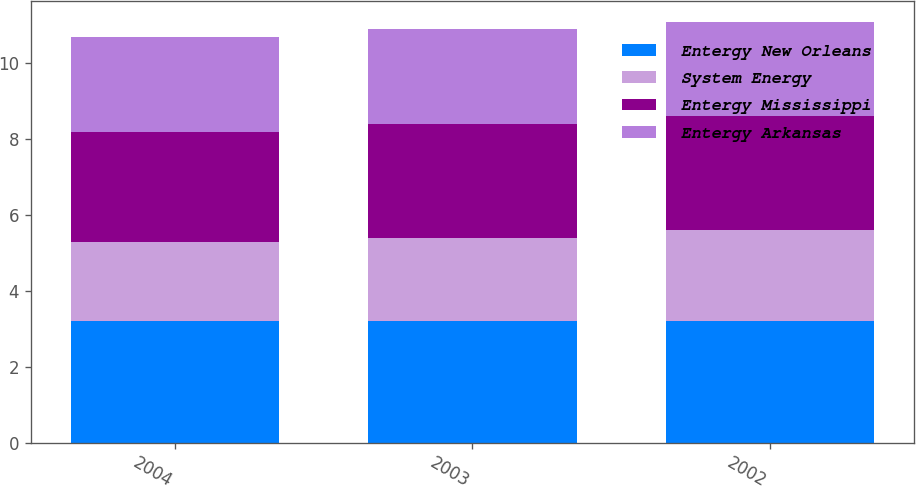<chart> <loc_0><loc_0><loc_500><loc_500><stacked_bar_chart><ecel><fcel>2004<fcel>2003<fcel>2002<nl><fcel>Entergy New Orleans<fcel>3.2<fcel>3.2<fcel>3.2<nl><fcel>System Energy<fcel>2.1<fcel>2.2<fcel>2.4<nl><fcel>Entergy Mississippi<fcel>2.9<fcel>3<fcel>3<nl><fcel>Entergy Arkansas<fcel>2.5<fcel>2.5<fcel>2.5<nl></chart> 